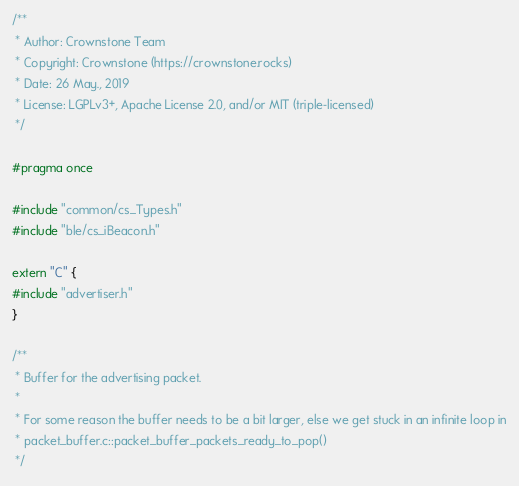Convert code to text. <code><loc_0><loc_0><loc_500><loc_500><_C_>/**
 * Author: Crownstone Team
 * Copyright: Crownstone (https://crownstone.rocks)
 * Date: 26 May., 2019
 * License: LGPLv3+, Apache License 2.0, and/or MIT (triple-licensed)
 */

#pragma once

#include "common/cs_Types.h"
#include "ble/cs_iBeacon.h"

extern "C" {
#include "advertiser.h"
}

/**
 * Buffer for the advertising packet.
 *
 * For some reason the buffer needs to be a bit larger, else we get stuck in an infinite loop in
 * packet_buffer.c::packet_buffer_packets_ready_to_pop()
 */</code> 